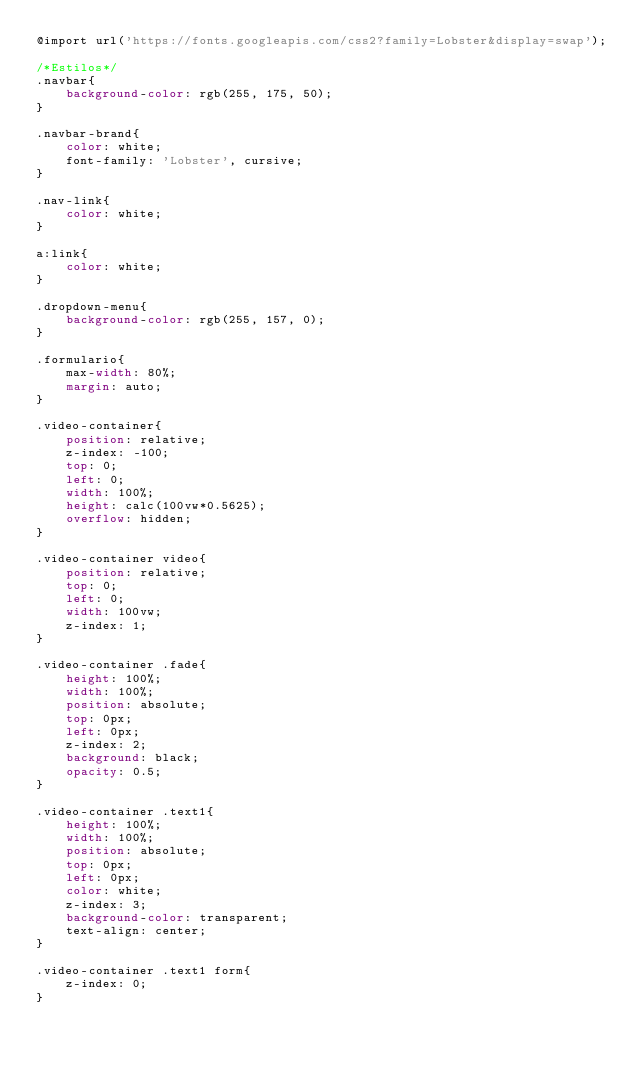<code> <loc_0><loc_0><loc_500><loc_500><_CSS_>@import url('https://fonts.googleapis.com/css2?family=Lobster&display=swap');

/*Estilos*/
.navbar{
    background-color: rgb(255, 175, 50);
}

.navbar-brand{
    color: white;
    font-family: 'Lobster', cursive;
}

.nav-link{
    color: white;
}

a:link{
    color: white;
}

.dropdown-menu{
    background-color: rgb(255, 157, 0);
}

.formulario{
    max-width: 80%;
    margin: auto;
}

.video-container{
    position: relative;
    z-index: -100;
    top: 0;
    left: 0;
    width: 100%;
    height: calc(100vw*0.5625);
    overflow: hidden;
}

.video-container video{
    position: relative;
    top: 0;
    left: 0;
    width: 100vw;
    z-index: 1;
}

.video-container .fade{
    height: 100%;
    width: 100%;
    position: absolute;
    top: 0px;
    left: 0px;
    z-index: 2;
    background: black;
    opacity: 0.5;
}

.video-container .text1{
    height: 100%;
    width: 100%;
    position: absolute;
    top: 0px;
    left: 0px;
    color: white;
    z-index: 3;
    background-color: transparent;
    text-align: center;
}

.video-container .text1 form{
    z-index: 0;
}</code> 